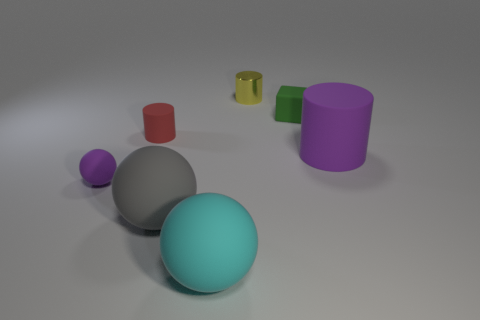Add 2 balls. How many objects exist? 9 Subtract all cylinders. How many objects are left? 4 Subtract 0 brown cylinders. How many objects are left? 7 Subtract all big cyan matte cylinders. Subtract all large rubber cylinders. How many objects are left? 6 Add 2 large gray rubber balls. How many large gray rubber balls are left? 3 Add 7 red cylinders. How many red cylinders exist? 8 